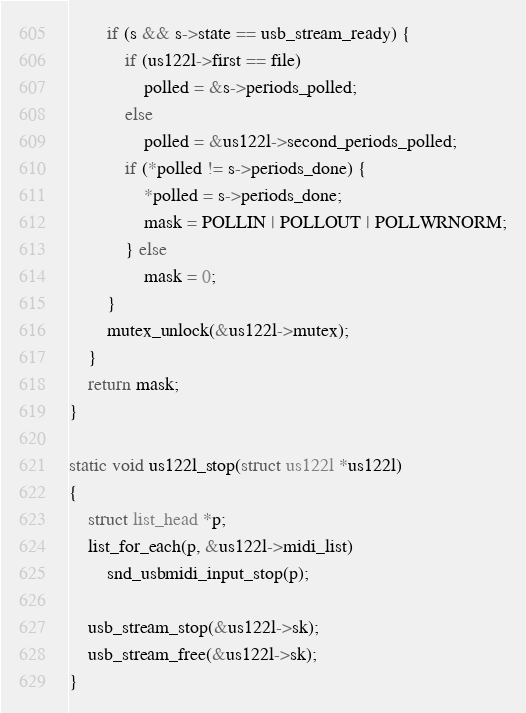<code> <loc_0><loc_0><loc_500><loc_500><_C_>		if (s && s->state == usb_stream_ready) {
			if (us122l->first == file)
				polled = &s->periods_polled;
			else
				polled = &us122l->second_periods_polled;
			if (*polled != s->periods_done) {
				*polled = s->periods_done;
				mask = POLLIN | POLLOUT | POLLWRNORM;
			} else
				mask = 0;
		}
		mutex_unlock(&us122l->mutex);
	}
	return mask;
}

static void us122l_stop(struct us122l *us122l)
{
	struct list_head *p;
	list_for_each(p, &us122l->midi_list)
		snd_usbmidi_input_stop(p);

	usb_stream_stop(&us122l->sk);
	usb_stream_free(&us122l->sk);
}
</code> 